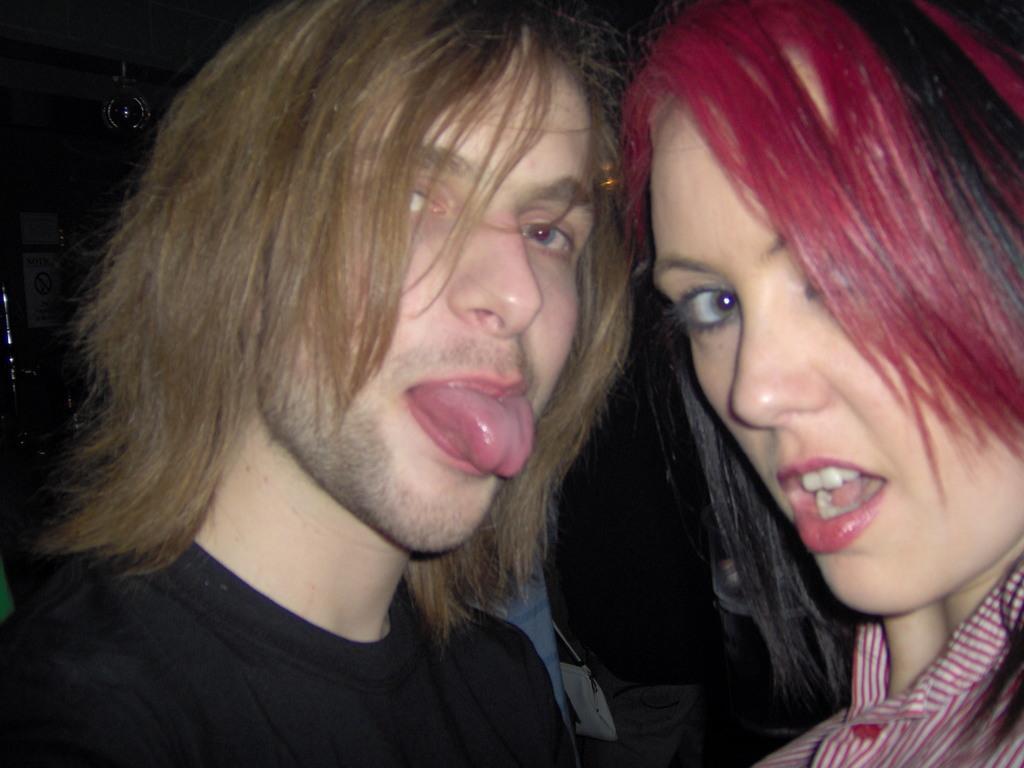How would you summarize this image in a sentence or two? In this image, we can see two people. In the middle, we can see a man wearing a black color shirt. On the right side, we can see a woman wearing a red and white color shirt. In the background, we can see black color. 